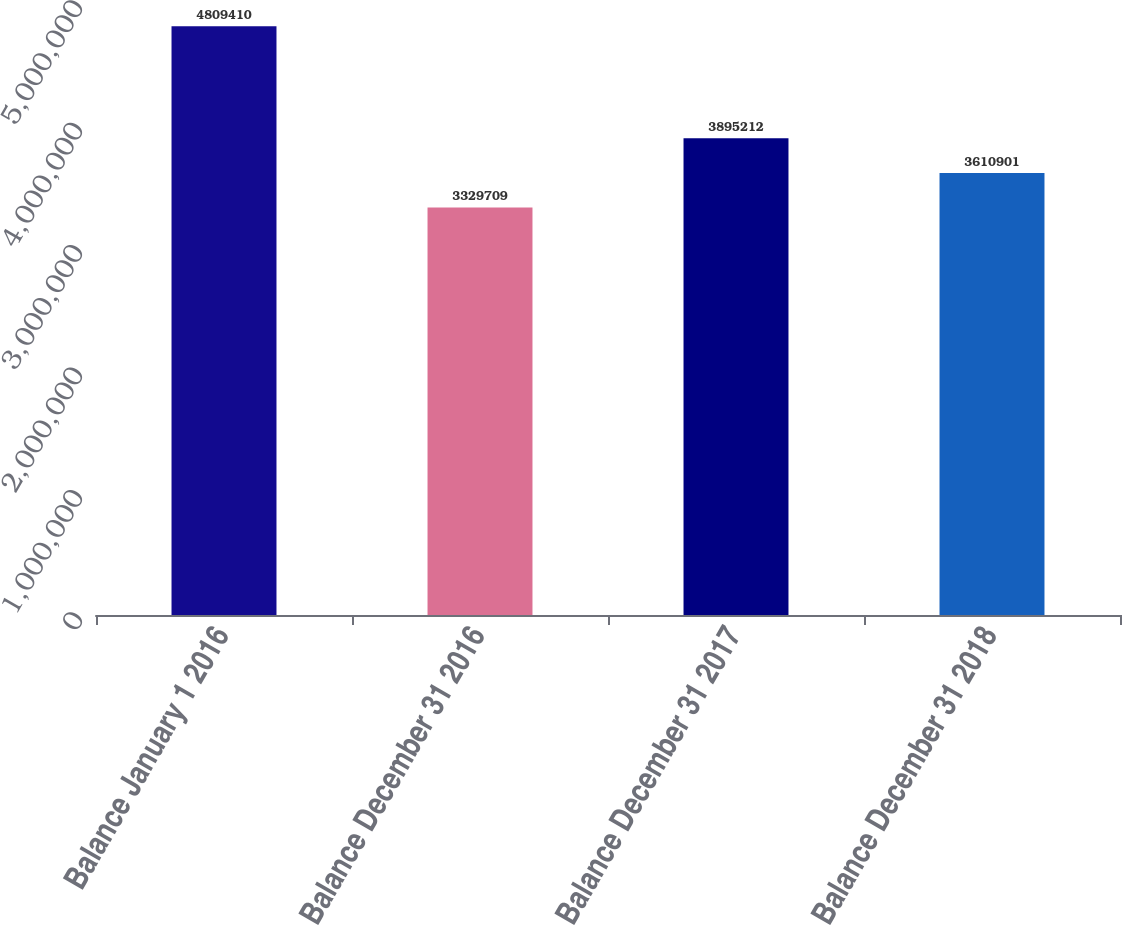<chart> <loc_0><loc_0><loc_500><loc_500><bar_chart><fcel>Balance January 1 2016<fcel>Balance December 31 2016<fcel>Balance December 31 2017<fcel>Balance December 31 2018<nl><fcel>4.80941e+06<fcel>3.32971e+06<fcel>3.89521e+06<fcel>3.6109e+06<nl></chart> 